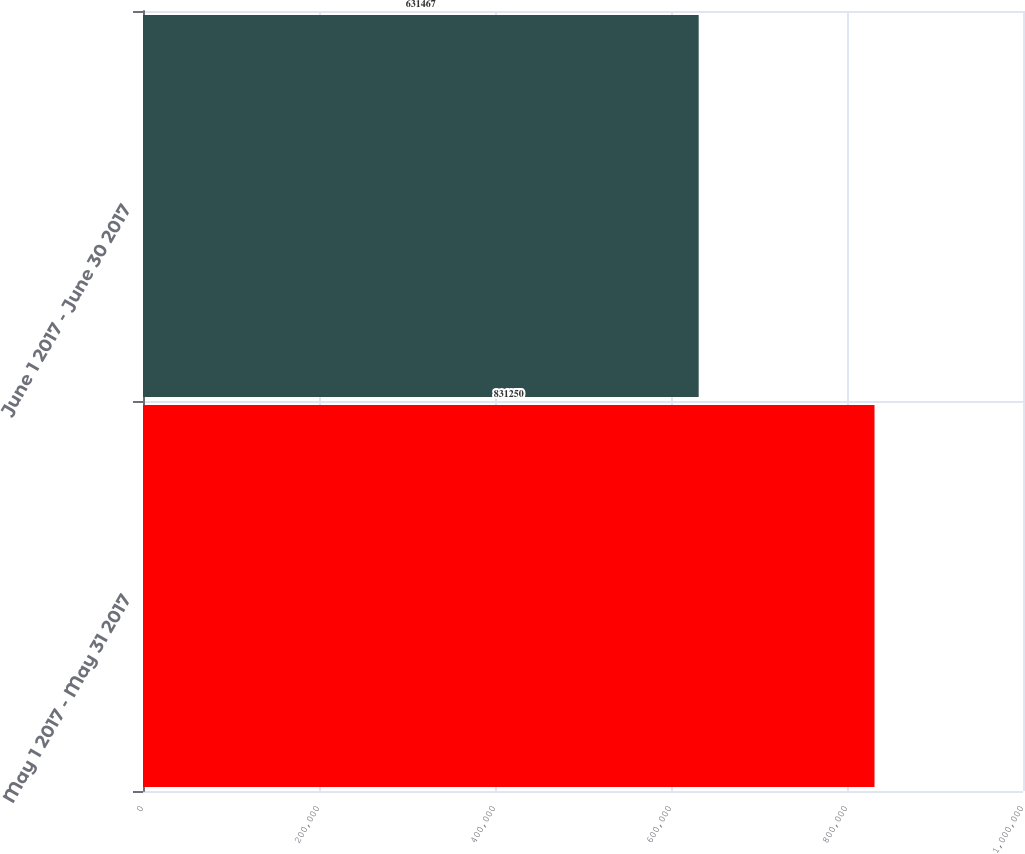<chart> <loc_0><loc_0><loc_500><loc_500><bar_chart><fcel>May 1 2017 - May 31 2017<fcel>June 1 2017 - June 30 2017<nl><fcel>831250<fcel>631467<nl></chart> 